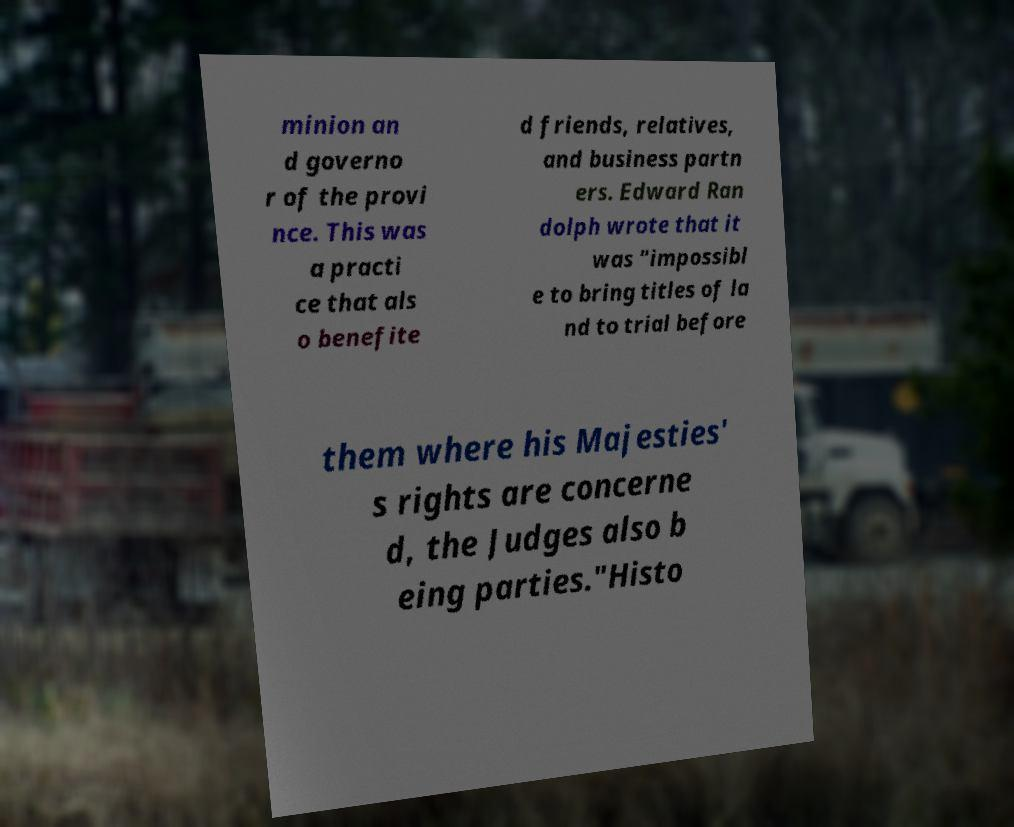For documentation purposes, I need the text within this image transcribed. Could you provide that? minion an d governo r of the provi nce. This was a practi ce that als o benefite d friends, relatives, and business partn ers. Edward Ran dolph wrote that it was "impossibl e to bring titles of la nd to trial before them where his Majesties' s rights are concerne d, the Judges also b eing parties."Histo 